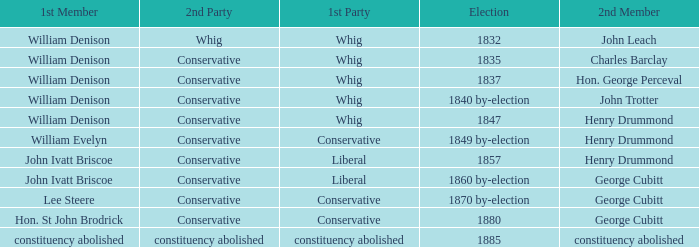Which party's 1st member is John Ivatt Briscoe in an election in 1857? Liberal. 